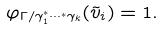<formula> <loc_0><loc_0><loc_500><loc_500>\varphi _ { \Gamma / { \gamma _ { 1 } ^ { * } \cdots ^ { * } \gamma _ { k } } } ( \tilde { v } _ { i } ) = 1 .</formula> 